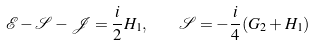<formula> <loc_0><loc_0><loc_500><loc_500>\mathcal { E } - \mathcal { S } - \mathcal { J } = \frac { i } { 2 } H _ { 1 } , \quad \mathcal { S } = - \frac { i } { 4 } ( G _ { 2 } + H _ { 1 } )</formula> 